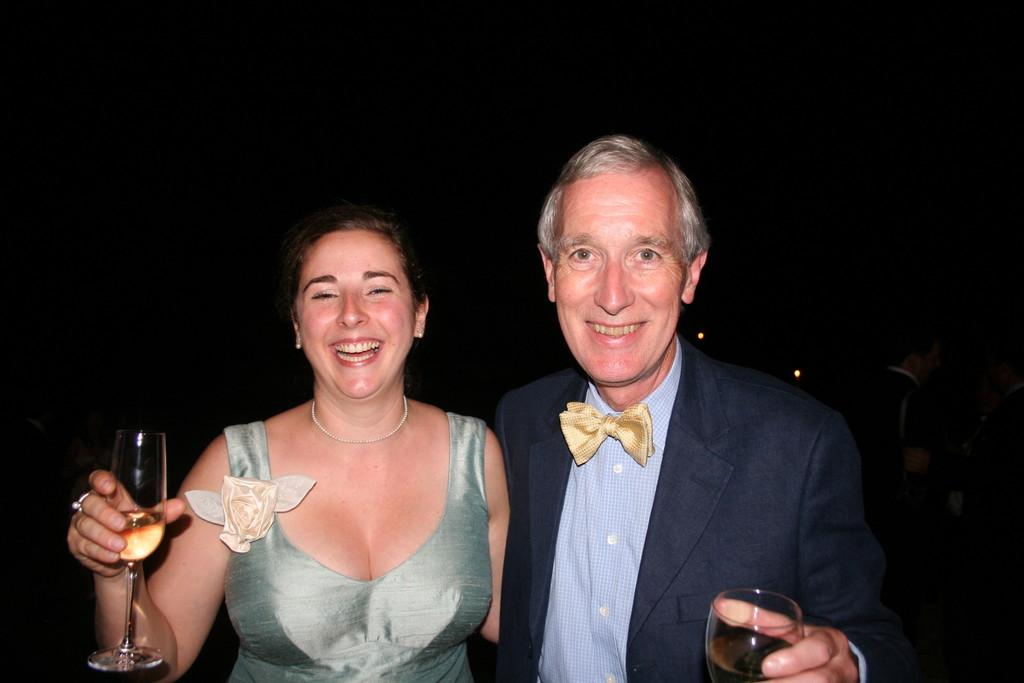Who are the people in the image? There is a man and a woman in the image. What are the man and woman holding? The man is holding a glass, and the woman is also holding a glass. What is the emotional state of the man and woman? The man and woman are laughing in the image. Is there a stream visible in the image? No, there is no stream present in the image. What type of wheel can be seen in the image? There is no wheel present in the image. 